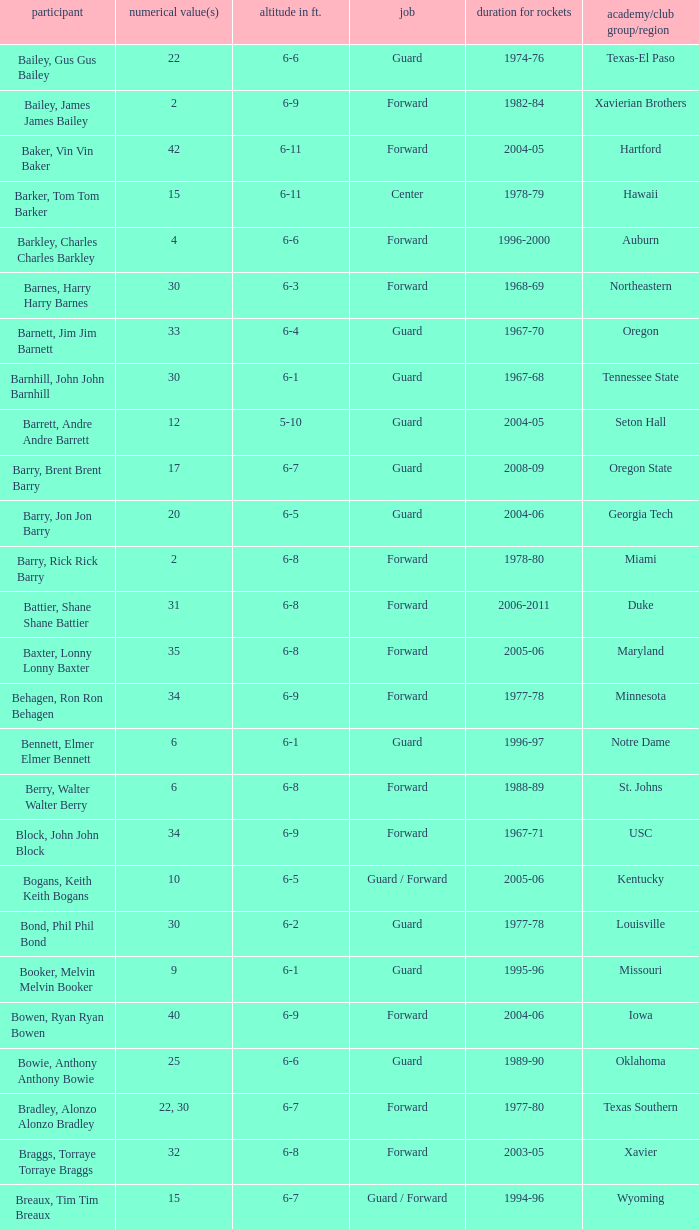What position is number 35 whose height is 6-6? Forward. Parse the table in full. {'header': ['participant', 'numerical value(s)', 'altitude in ft.', 'job', 'duration for rockets', 'academy/club group/region'], 'rows': [['Bailey, Gus Gus Bailey', '22', '6-6', 'Guard', '1974-76', 'Texas-El Paso'], ['Bailey, James James Bailey', '2', '6-9', 'Forward', '1982-84', 'Xavierian Brothers'], ['Baker, Vin Vin Baker', '42', '6-11', 'Forward', '2004-05', 'Hartford'], ['Barker, Tom Tom Barker', '15', '6-11', 'Center', '1978-79', 'Hawaii'], ['Barkley, Charles Charles Barkley', '4', '6-6', 'Forward', '1996-2000', 'Auburn'], ['Barnes, Harry Harry Barnes', '30', '6-3', 'Forward', '1968-69', 'Northeastern'], ['Barnett, Jim Jim Barnett', '33', '6-4', 'Guard', '1967-70', 'Oregon'], ['Barnhill, John John Barnhill', '30', '6-1', 'Guard', '1967-68', 'Tennessee State'], ['Barrett, Andre Andre Barrett', '12', '5-10', 'Guard', '2004-05', 'Seton Hall'], ['Barry, Brent Brent Barry', '17', '6-7', 'Guard', '2008-09', 'Oregon State'], ['Barry, Jon Jon Barry', '20', '6-5', 'Guard', '2004-06', 'Georgia Tech'], ['Barry, Rick Rick Barry', '2', '6-8', 'Forward', '1978-80', 'Miami'], ['Battier, Shane Shane Battier', '31', '6-8', 'Forward', '2006-2011', 'Duke'], ['Baxter, Lonny Lonny Baxter', '35', '6-8', 'Forward', '2005-06', 'Maryland'], ['Behagen, Ron Ron Behagen', '34', '6-9', 'Forward', '1977-78', 'Minnesota'], ['Bennett, Elmer Elmer Bennett', '6', '6-1', 'Guard', '1996-97', 'Notre Dame'], ['Berry, Walter Walter Berry', '6', '6-8', 'Forward', '1988-89', 'St. Johns'], ['Block, John John Block', '34', '6-9', 'Forward', '1967-71', 'USC'], ['Bogans, Keith Keith Bogans', '10', '6-5', 'Guard / Forward', '2005-06', 'Kentucky'], ['Bond, Phil Phil Bond', '30', '6-2', 'Guard', '1977-78', 'Louisville'], ['Booker, Melvin Melvin Booker', '9', '6-1', 'Guard', '1995-96', 'Missouri'], ['Bowen, Ryan Ryan Bowen', '40', '6-9', 'Forward', '2004-06', 'Iowa'], ['Bowie, Anthony Anthony Bowie', '25', '6-6', 'Guard', '1989-90', 'Oklahoma'], ['Bradley, Alonzo Alonzo Bradley', '22, 30', '6-7', 'Forward', '1977-80', 'Texas Southern'], ['Braggs, Torraye Torraye Braggs', '32', '6-8', 'Forward', '2003-05', 'Xavier'], ['Breaux, Tim Tim Breaux', '15', '6-7', 'Guard / Forward', '1994-96', 'Wyoming'], ['Britt, Tyrone Tyrone Britt', '31', '6-4', 'Guard', '1967-68', 'Johnson C. Smith'], ['Brooks, Aaron Aaron Brooks', '0', '6-0', 'Guard', '2007-2011, 2013', 'Oregon'], ['Brooks, Scott Scott Brooks', '1', '5-11', 'Guard', '1992-95', 'UC-Irvine'], ['Brown, Chucky Chucky Brown', '52', '6-8', 'Forward', '1994-96', 'North Carolina'], ['Brown, Tony Tony Brown', '35', '6-6', 'Forward', '1988-89', 'Arkansas'], ['Brown, Tierre Tierre Brown', '10', '6-2', 'Guard', '2001-02', 'McNesse State'], ['Brunson, Rick Rick Brunson', '9', '6-4', 'Guard', '2005-06', 'Temple'], ['Bryant, Joe Joe Bryant', '22', '6-9', 'Forward / Guard', '1982-83', 'LaSalle'], ['Bryant, Mark Mark Bryant', '2', '6-9', 'Forward', '1995-96', 'Seton Hall'], ['Budinger, Chase Chase Budinger', '10', '6-7', 'Forward', '2009-2012', 'Arizona'], ['Bullard, Matt Matt Bullard', '50', '6-10', 'Forward', '1990-94, 1996-2001', 'Iowa']]} 